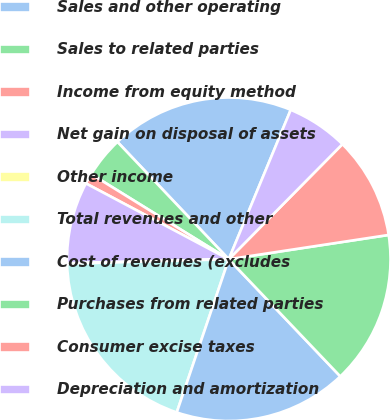<chart> <loc_0><loc_0><loc_500><loc_500><pie_chart><fcel>Sales and other operating<fcel>Sales to related parties<fcel>Income from equity method<fcel>Net gain on disposal of assets<fcel>Other income<fcel>Total revenues and other<fcel>Cost of revenues (excludes<fcel>Purchases from related parties<fcel>Consumer excise taxes<fcel>Depreciation and amortization<nl><fcel>18.34%<fcel>4.1%<fcel>1.05%<fcel>8.17%<fcel>0.04%<fcel>19.35%<fcel>17.32%<fcel>15.29%<fcel>10.2%<fcel>6.14%<nl></chart> 